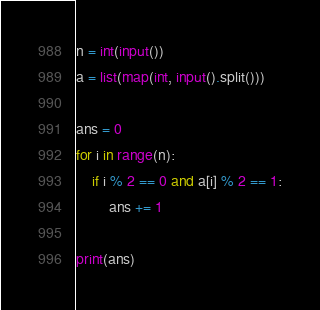Convert code to text. <code><loc_0><loc_0><loc_500><loc_500><_Python_>n = int(input())
a = list(map(int, input().split()))

ans = 0
for i in range(n):
    if i % 2 == 0 and a[i] % 2 == 1:
        ans += 1

print(ans)
</code> 